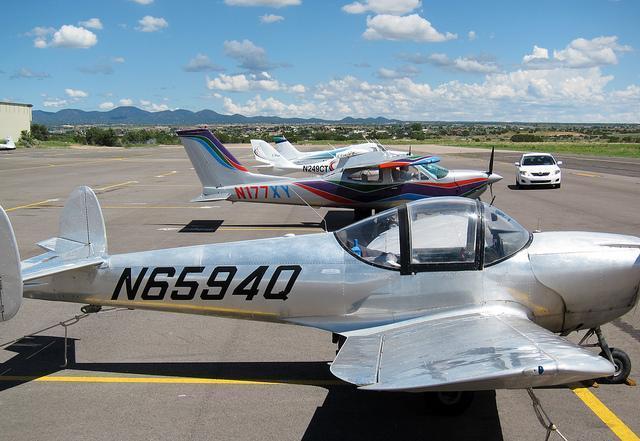How many airplanes are visible?
Give a very brief answer. 3. 